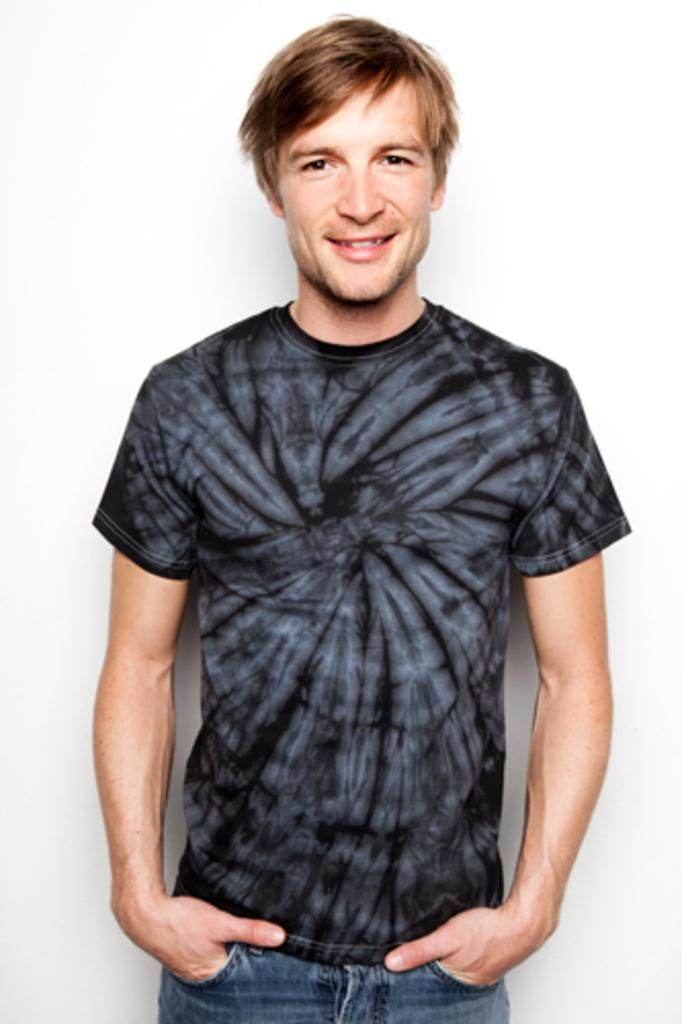What is the main subject of the image? There is a person in the image. What is the person doing in the image? The person is standing and posing for a picture. What can be seen in the background of the image? There is a white-colored wall in the background of the image. What type of calculator is the person holding in the image? There is no calculator present in the image. Can you see any wings on the person in the image? There are no wings visible on the person in the image. 